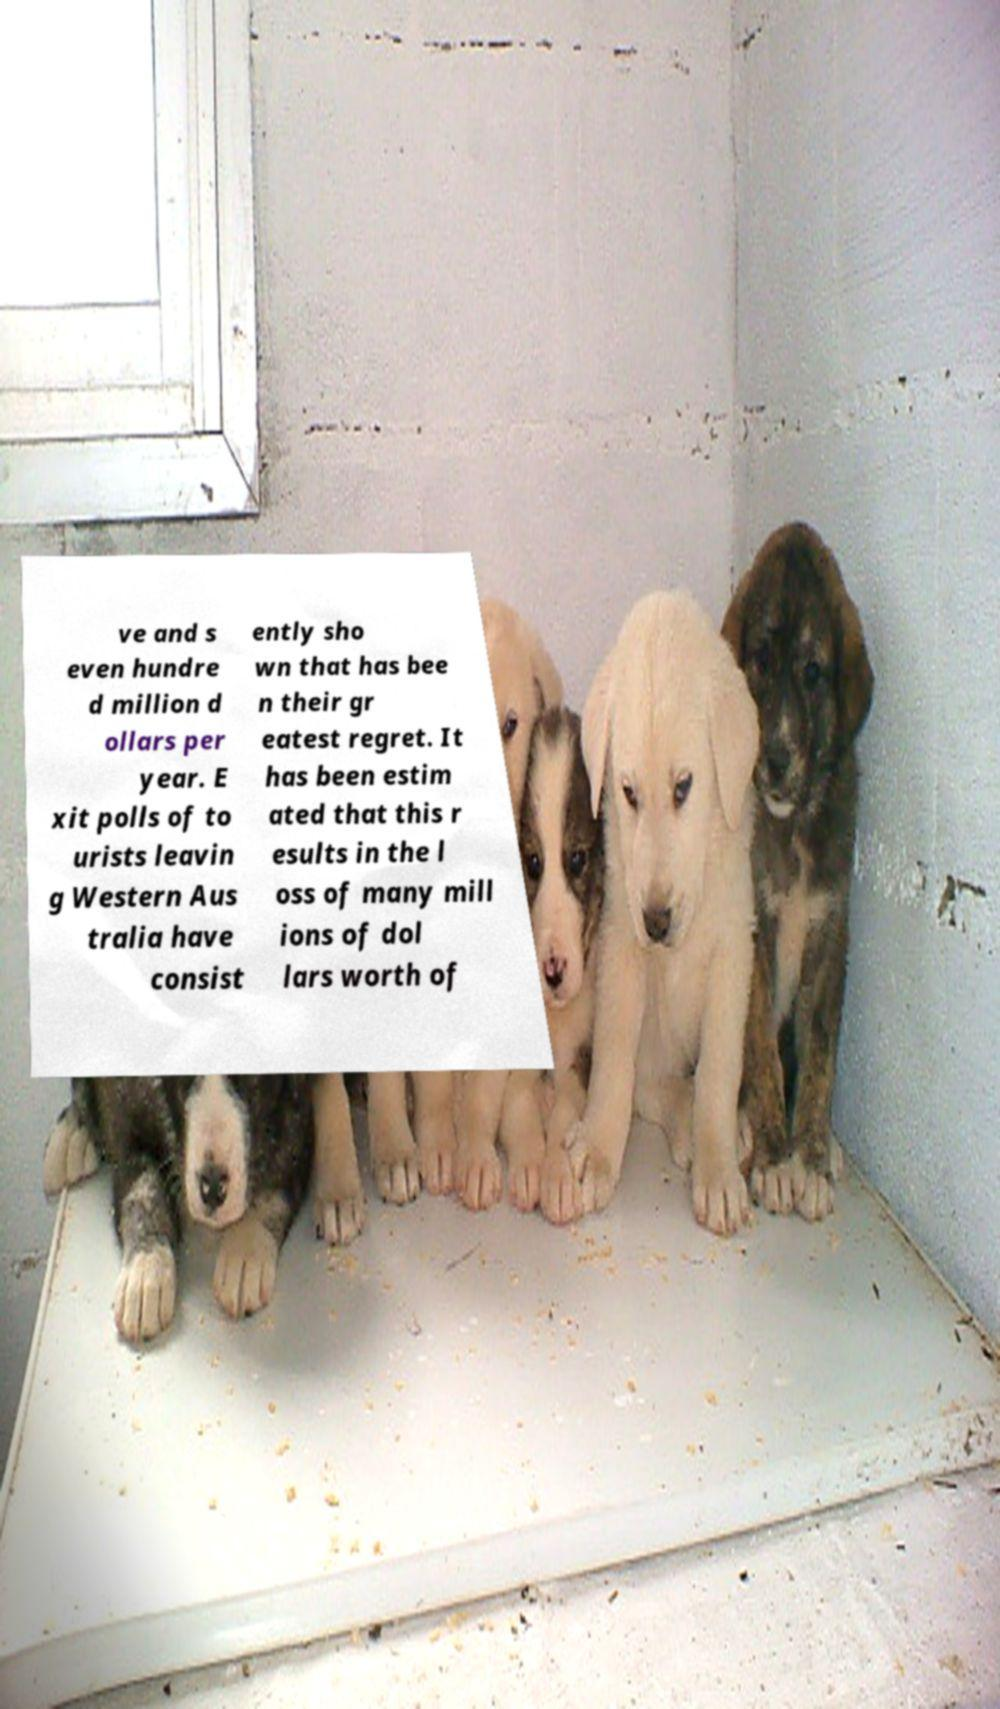Please read and relay the text visible in this image. What does it say? ve and s even hundre d million d ollars per year. E xit polls of to urists leavin g Western Aus tralia have consist ently sho wn that has bee n their gr eatest regret. It has been estim ated that this r esults in the l oss of many mill ions of dol lars worth of 